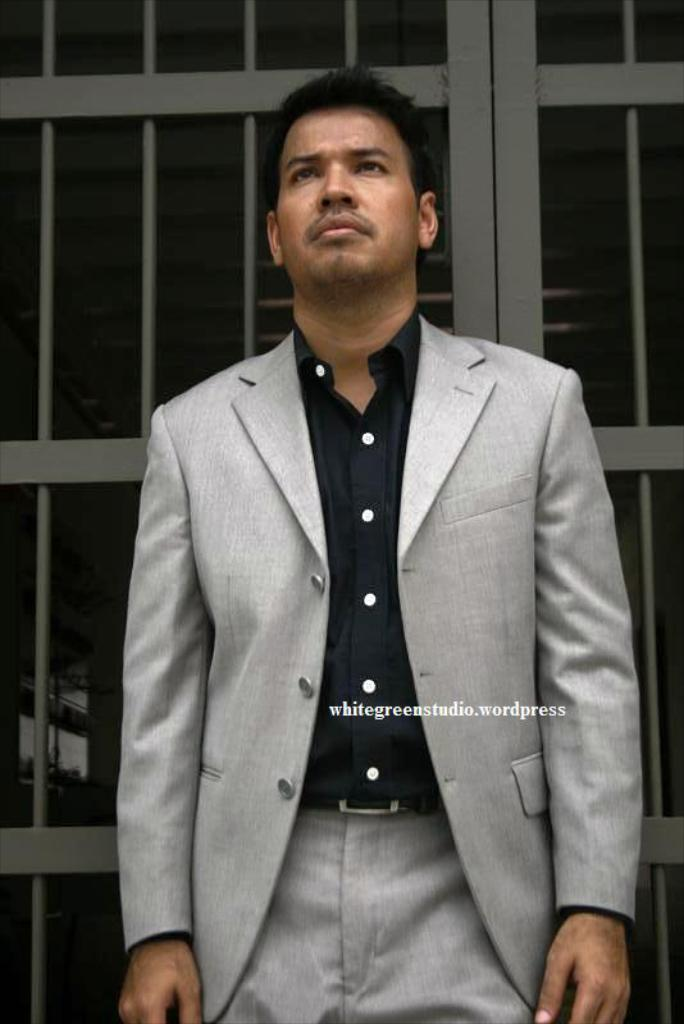Who is present in the image? There is a man in the image. What is the man wearing? The man is wearing a suit. What is the man doing in the image? The man is standing and looking upwards. What can be seen in the background of the image? There is a metal frame in the background of the image. What has been added to the image? There is edited text on the image. What type of winter sport is the man participating in the image? The image does not depict any winter sports or activities, and the man is simply standing and looking upwards. How many circles can be seen in the image? There are no circles present in the image. 